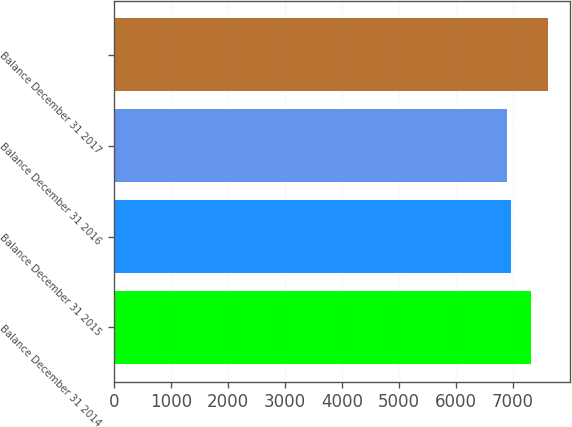Convert chart. <chart><loc_0><loc_0><loc_500><loc_500><bar_chart><fcel>Balance December 31 2014<fcel>Balance December 31 2015<fcel>Balance December 31 2016<fcel>Balance December 31 2017<nl><fcel>7315.9<fcel>6972.84<fcel>6901.1<fcel>7618.5<nl></chart> 